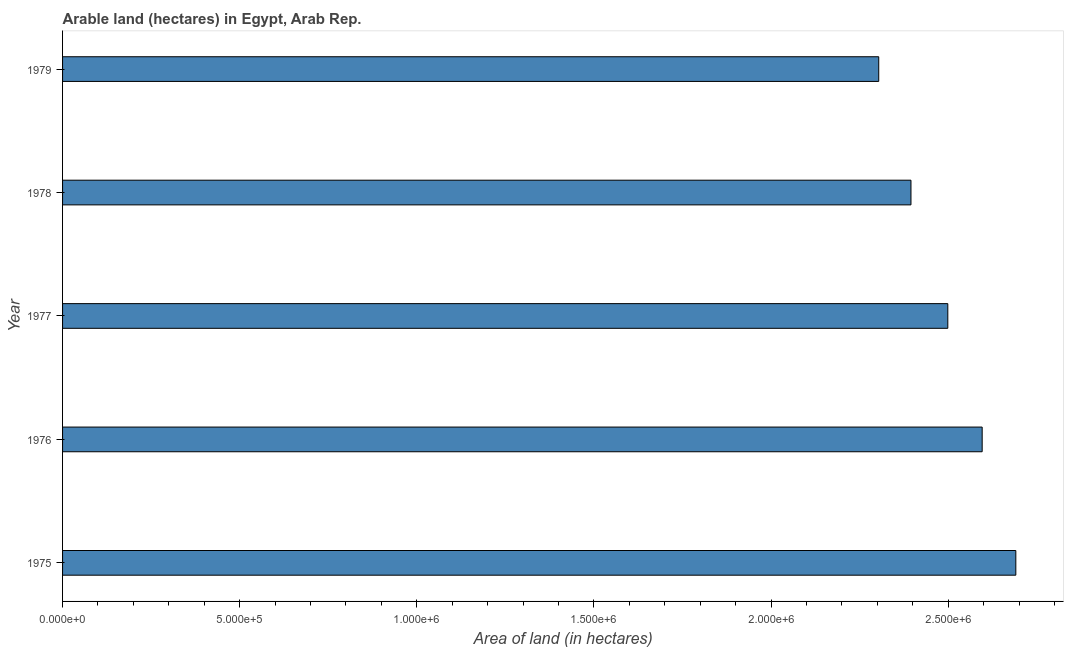Does the graph contain any zero values?
Offer a very short reply. No. Does the graph contain grids?
Make the answer very short. No. What is the title of the graph?
Provide a succinct answer. Arable land (hectares) in Egypt, Arab Rep. What is the label or title of the X-axis?
Your answer should be very brief. Area of land (in hectares). What is the label or title of the Y-axis?
Provide a succinct answer. Year. What is the area of land in 1978?
Your answer should be very brief. 2.40e+06. Across all years, what is the maximum area of land?
Give a very brief answer. 2.69e+06. Across all years, what is the minimum area of land?
Ensure brevity in your answer.  2.30e+06. In which year was the area of land maximum?
Provide a succinct answer. 1975. In which year was the area of land minimum?
Keep it short and to the point. 1979. What is the sum of the area of land?
Ensure brevity in your answer.  1.25e+07. What is the difference between the area of land in 1975 and 1976?
Make the answer very short. 9.50e+04. What is the average area of land per year?
Your answer should be very brief. 2.50e+06. What is the median area of land?
Your answer should be very brief. 2.50e+06. In how many years, is the area of land greater than 1900000 hectares?
Give a very brief answer. 5. What is the ratio of the area of land in 1976 to that in 1978?
Make the answer very short. 1.08. What is the difference between the highest and the second highest area of land?
Offer a very short reply. 9.50e+04. Is the sum of the area of land in 1977 and 1978 greater than the maximum area of land across all years?
Offer a very short reply. Yes. What is the difference between the highest and the lowest area of land?
Offer a very short reply. 3.87e+05. In how many years, is the area of land greater than the average area of land taken over all years?
Give a very brief answer. 3. How many bars are there?
Provide a succinct answer. 5. What is the Area of land (in hectares) in 1975?
Your response must be concise. 2.69e+06. What is the Area of land (in hectares) of 1976?
Your answer should be very brief. 2.60e+06. What is the Area of land (in hectares) in 1977?
Ensure brevity in your answer.  2.50e+06. What is the Area of land (in hectares) of 1978?
Offer a very short reply. 2.40e+06. What is the Area of land (in hectares) in 1979?
Offer a terse response. 2.30e+06. What is the difference between the Area of land (in hectares) in 1975 and 1976?
Your answer should be compact. 9.50e+04. What is the difference between the Area of land (in hectares) in 1975 and 1977?
Your answer should be very brief. 1.92e+05. What is the difference between the Area of land (in hectares) in 1975 and 1978?
Give a very brief answer. 2.96e+05. What is the difference between the Area of land (in hectares) in 1975 and 1979?
Your answer should be compact. 3.87e+05. What is the difference between the Area of land (in hectares) in 1976 and 1977?
Provide a succinct answer. 9.70e+04. What is the difference between the Area of land (in hectares) in 1976 and 1978?
Offer a terse response. 2.01e+05. What is the difference between the Area of land (in hectares) in 1976 and 1979?
Offer a terse response. 2.92e+05. What is the difference between the Area of land (in hectares) in 1977 and 1978?
Keep it short and to the point. 1.04e+05. What is the difference between the Area of land (in hectares) in 1977 and 1979?
Your answer should be very brief. 1.95e+05. What is the difference between the Area of land (in hectares) in 1978 and 1979?
Your answer should be compact. 9.10e+04. What is the ratio of the Area of land (in hectares) in 1975 to that in 1977?
Provide a succinct answer. 1.08. What is the ratio of the Area of land (in hectares) in 1975 to that in 1978?
Make the answer very short. 1.12. What is the ratio of the Area of land (in hectares) in 1975 to that in 1979?
Provide a succinct answer. 1.17. What is the ratio of the Area of land (in hectares) in 1976 to that in 1977?
Offer a terse response. 1.04. What is the ratio of the Area of land (in hectares) in 1976 to that in 1978?
Your answer should be compact. 1.08. What is the ratio of the Area of land (in hectares) in 1976 to that in 1979?
Keep it short and to the point. 1.13. What is the ratio of the Area of land (in hectares) in 1977 to that in 1978?
Make the answer very short. 1.04. What is the ratio of the Area of land (in hectares) in 1977 to that in 1979?
Offer a very short reply. 1.08. What is the ratio of the Area of land (in hectares) in 1978 to that in 1979?
Offer a very short reply. 1.04. 